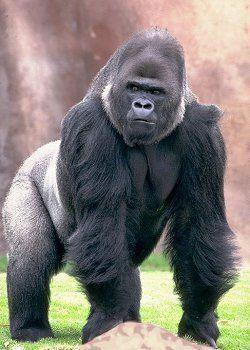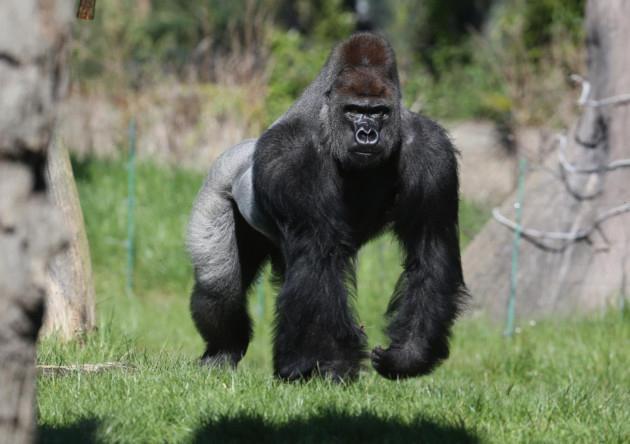The first image is the image on the left, the second image is the image on the right. Given the left and right images, does the statement "Each image features exactly one gorilla, a fierce-looking adult male." hold true? Answer yes or no. Yes. The first image is the image on the left, the second image is the image on the right. Assess this claim about the two images: "At least one of the images show a baby gorilla". Correct or not? Answer yes or no. No. 